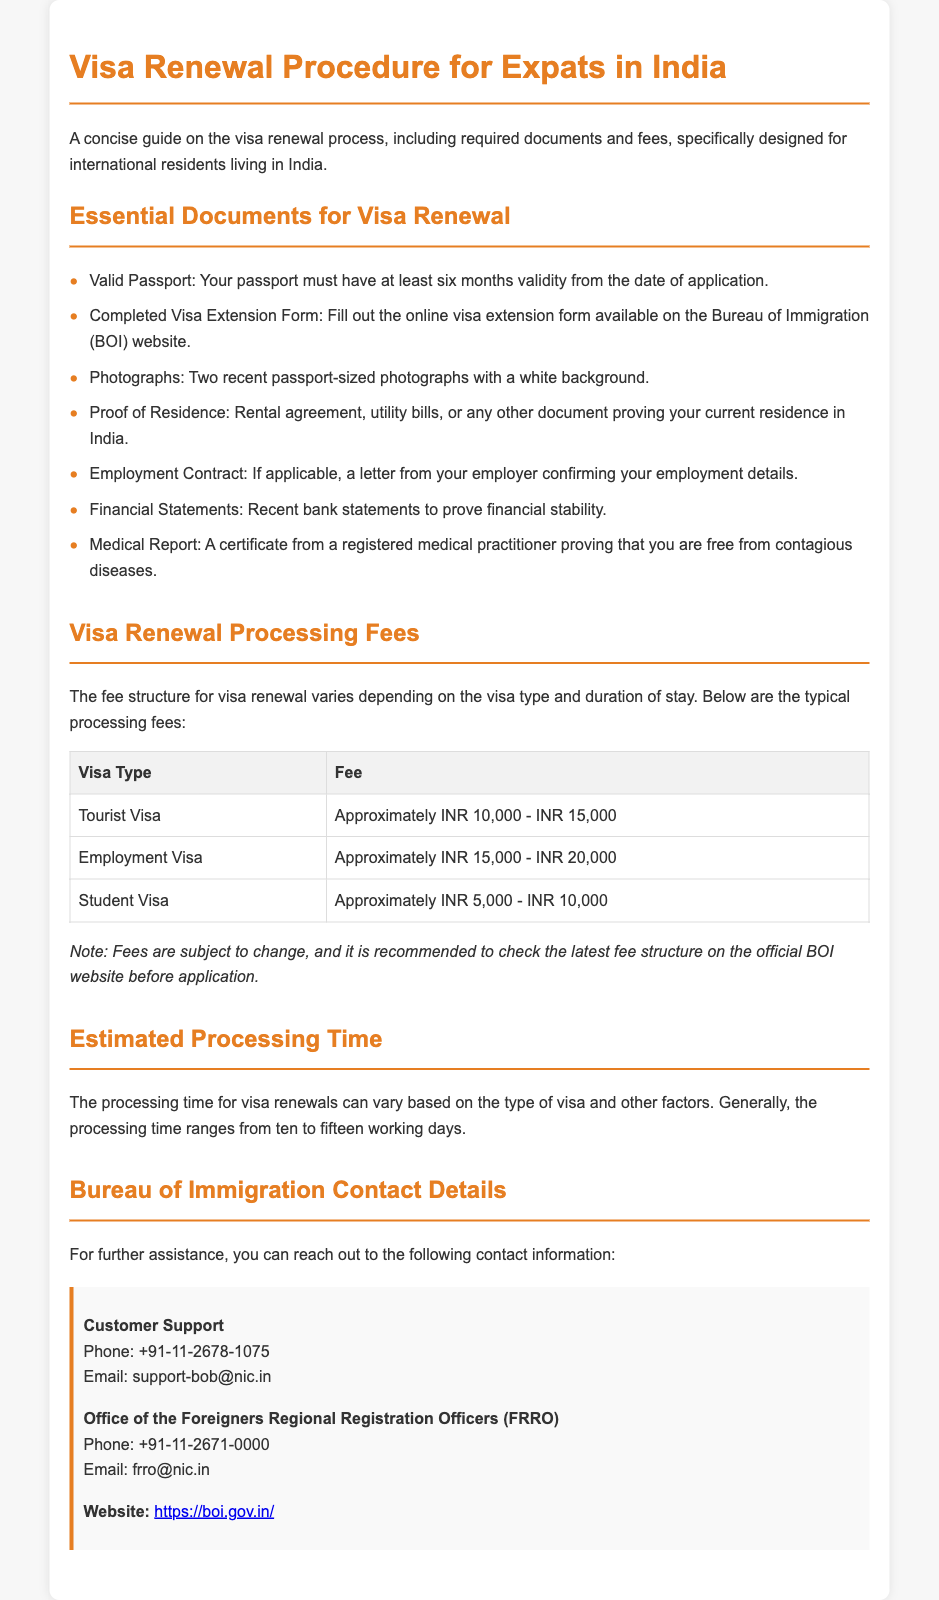What is the main purpose of the document? The document serves as a guide for the visa renewal process, specifically for international residents living in India.
Answer: Visa Renewal Guide for Expats in India How many passport-sized photographs are required for visa renewal? The document states the number of photographs needed for visa renewal.
Answer: Two What is the fee range for a Tourist Visa renewal? The fee structure for visa renewal varies by type; the document specifies the fee range for a Tourist Visa.
Answer: Approximately INR 10,000 - INR 15,000 What is the estimated processing time for visa renewals? The document provides an estimated range of processing time for visa renewals based on current information.
Answer: Ten to fifteen working days What type of document is needed to prove residence in India? The document lists one specific type of document that can prove your residence as part of the visa renewal process.
Answer: Rental agreement Which organization handles visa renewals? The contact information provided in the document indicates the authority responsible for visa renewals.
Answer: Bureau of Immigration (BOI) What is the purpose of the medical report? The document states a specific requirement for health verification in the visa renewal process.
Answer: To prove that you are free from contagious diseases What should you do before submitting your visa application? The document advises checking for certain information before applying for a visa renewal, specifically regarding fees.
Answer: Check the latest fee structure What is one of the listed employment documents for visa renewal? The document specifies a particular type of employment verification needed in the visa renewal process.
Answer: Employment Contract 